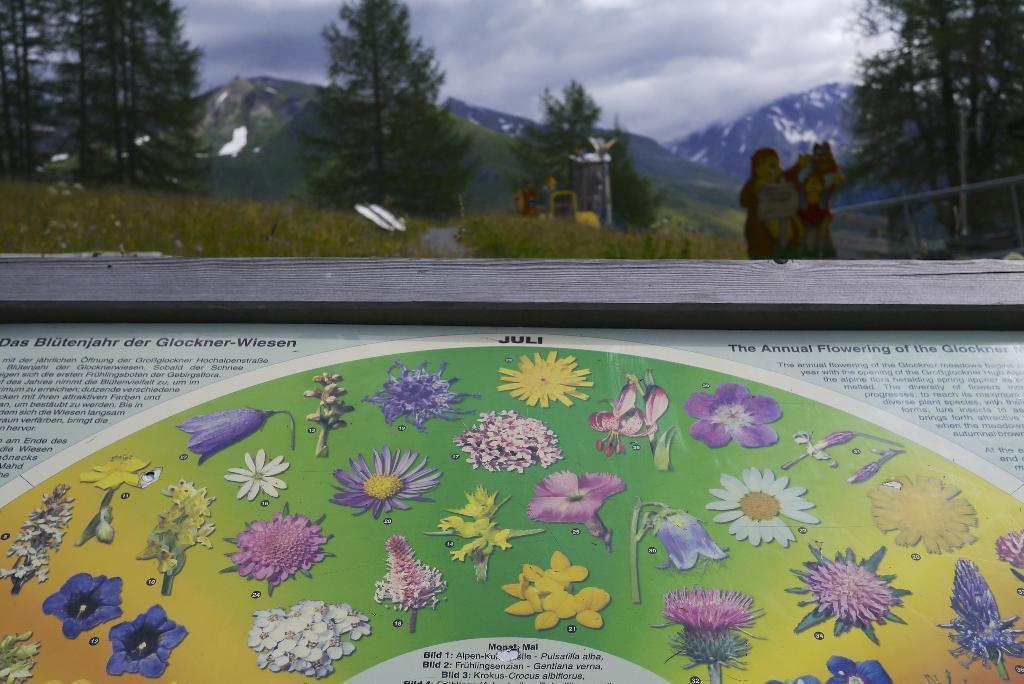Could you give a brief overview of what you see in this image? In the given image i can see a wooden object with some text and in the background i can see the trees,mountains and sky. 